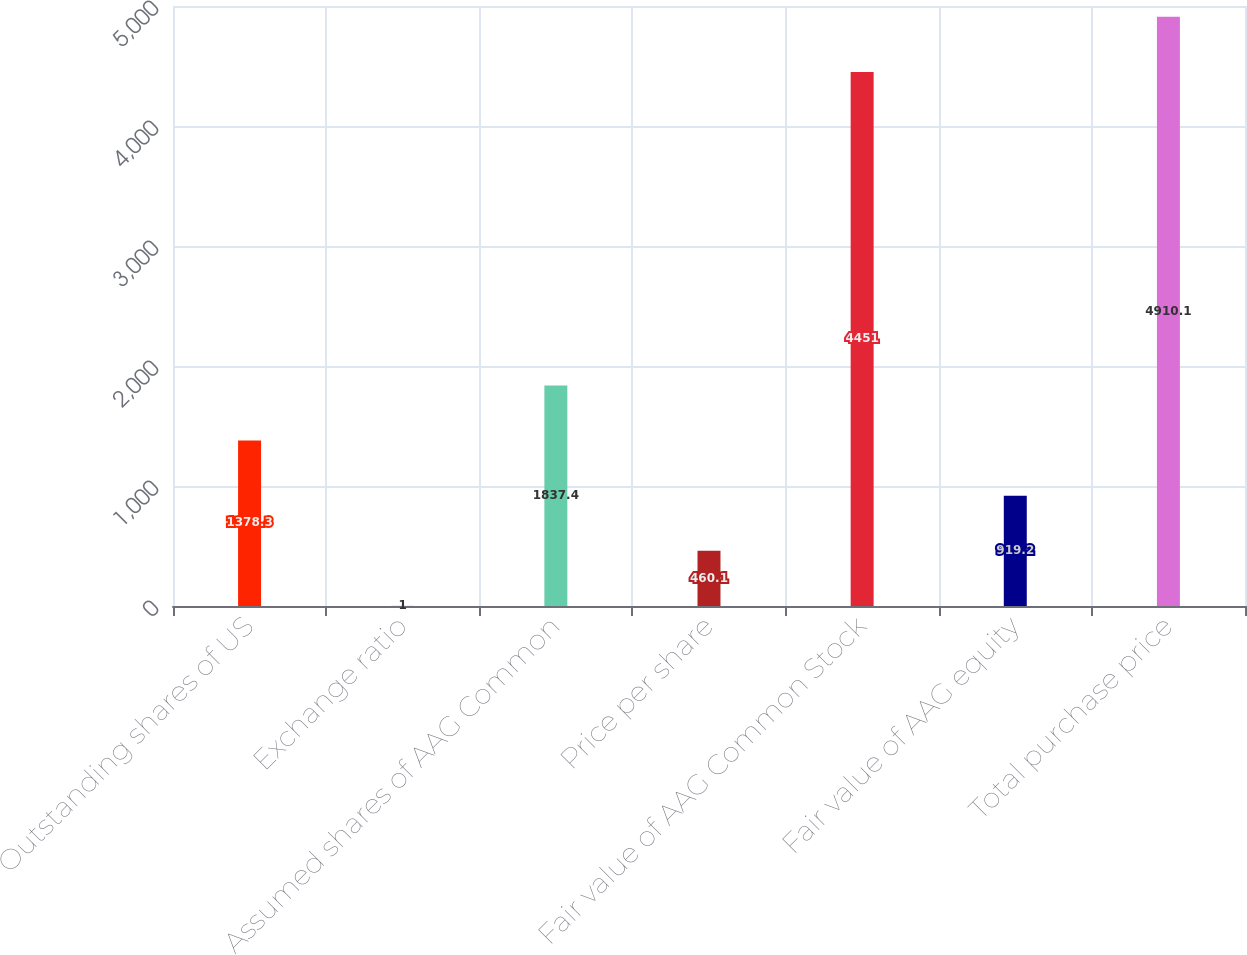Convert chart. <chart><loc_0><loc_0><loc_500><loc_500><bar_chart><fcel>Outstanding shares of US<fcel>Exchange ratio<fcel>Assumed shares of AAG Common<fcel>Price per share<fcel>Fair value of AAG Common Stock<fcel>Fair value of AAG equity<fcel>Total purchase price<nl><fcel>1378.3<fcel>1<fcel>1837.4<fcel>460.1<fcel>4451<fcel>919.2<fcel>4910.1<nl></chart> 